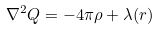Convert formula to latex. <formula><loc_0><loc_0><loc_500><loc_500>\nabla ^ { 2 } Q = - 4 \pi \rho + \lambda ( r )</formula> 